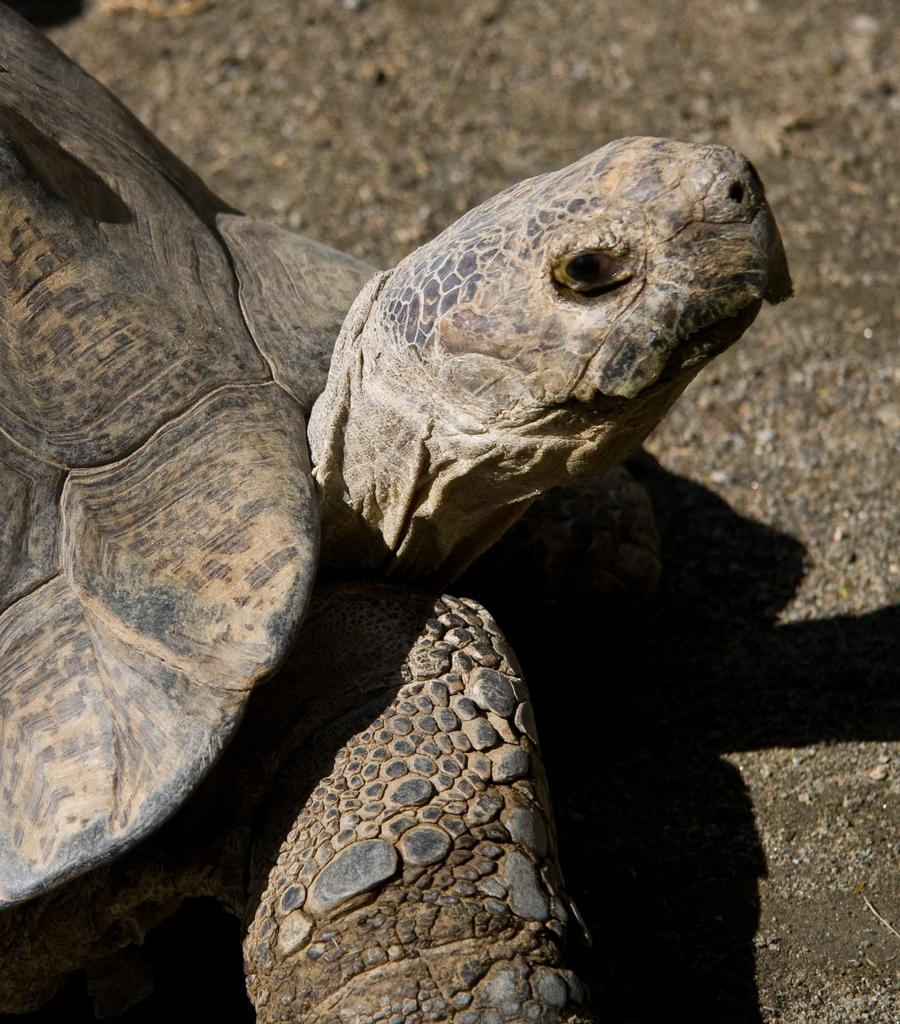What type of animal is in the image? There is a tortoise in the image. What is the tortoise resting on? The tortoise is on a stone. What type of fruit is the tortoise holding in the image? There is no fruit present in the image, and the tortoise is not holding anything. 